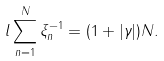Convert formula to latex. <formula><loc_0><loc_0><loc_500><loc_500>l \sum _ { n = 1 } ^ { N } \xi _ { n } ^ { - 1 } = ( 1 + | \gamma | ) N .</formula> 